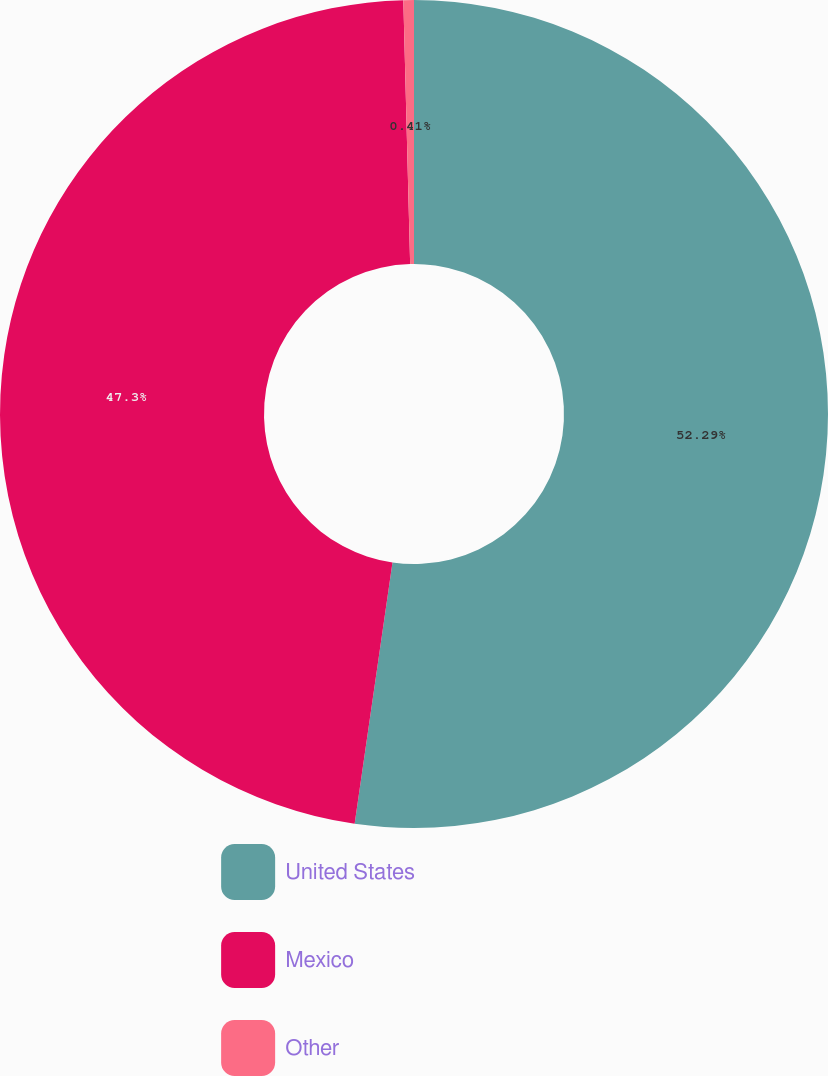Convert chart. <chart><loc_0><loc_0><loc_500><loc_500><pie_chart><fcel>United States<fcel>Mexico<fcel>Other<nl><fcel>52.29%<fcel>47.3%<fcel>0.41%<nl></chart> 